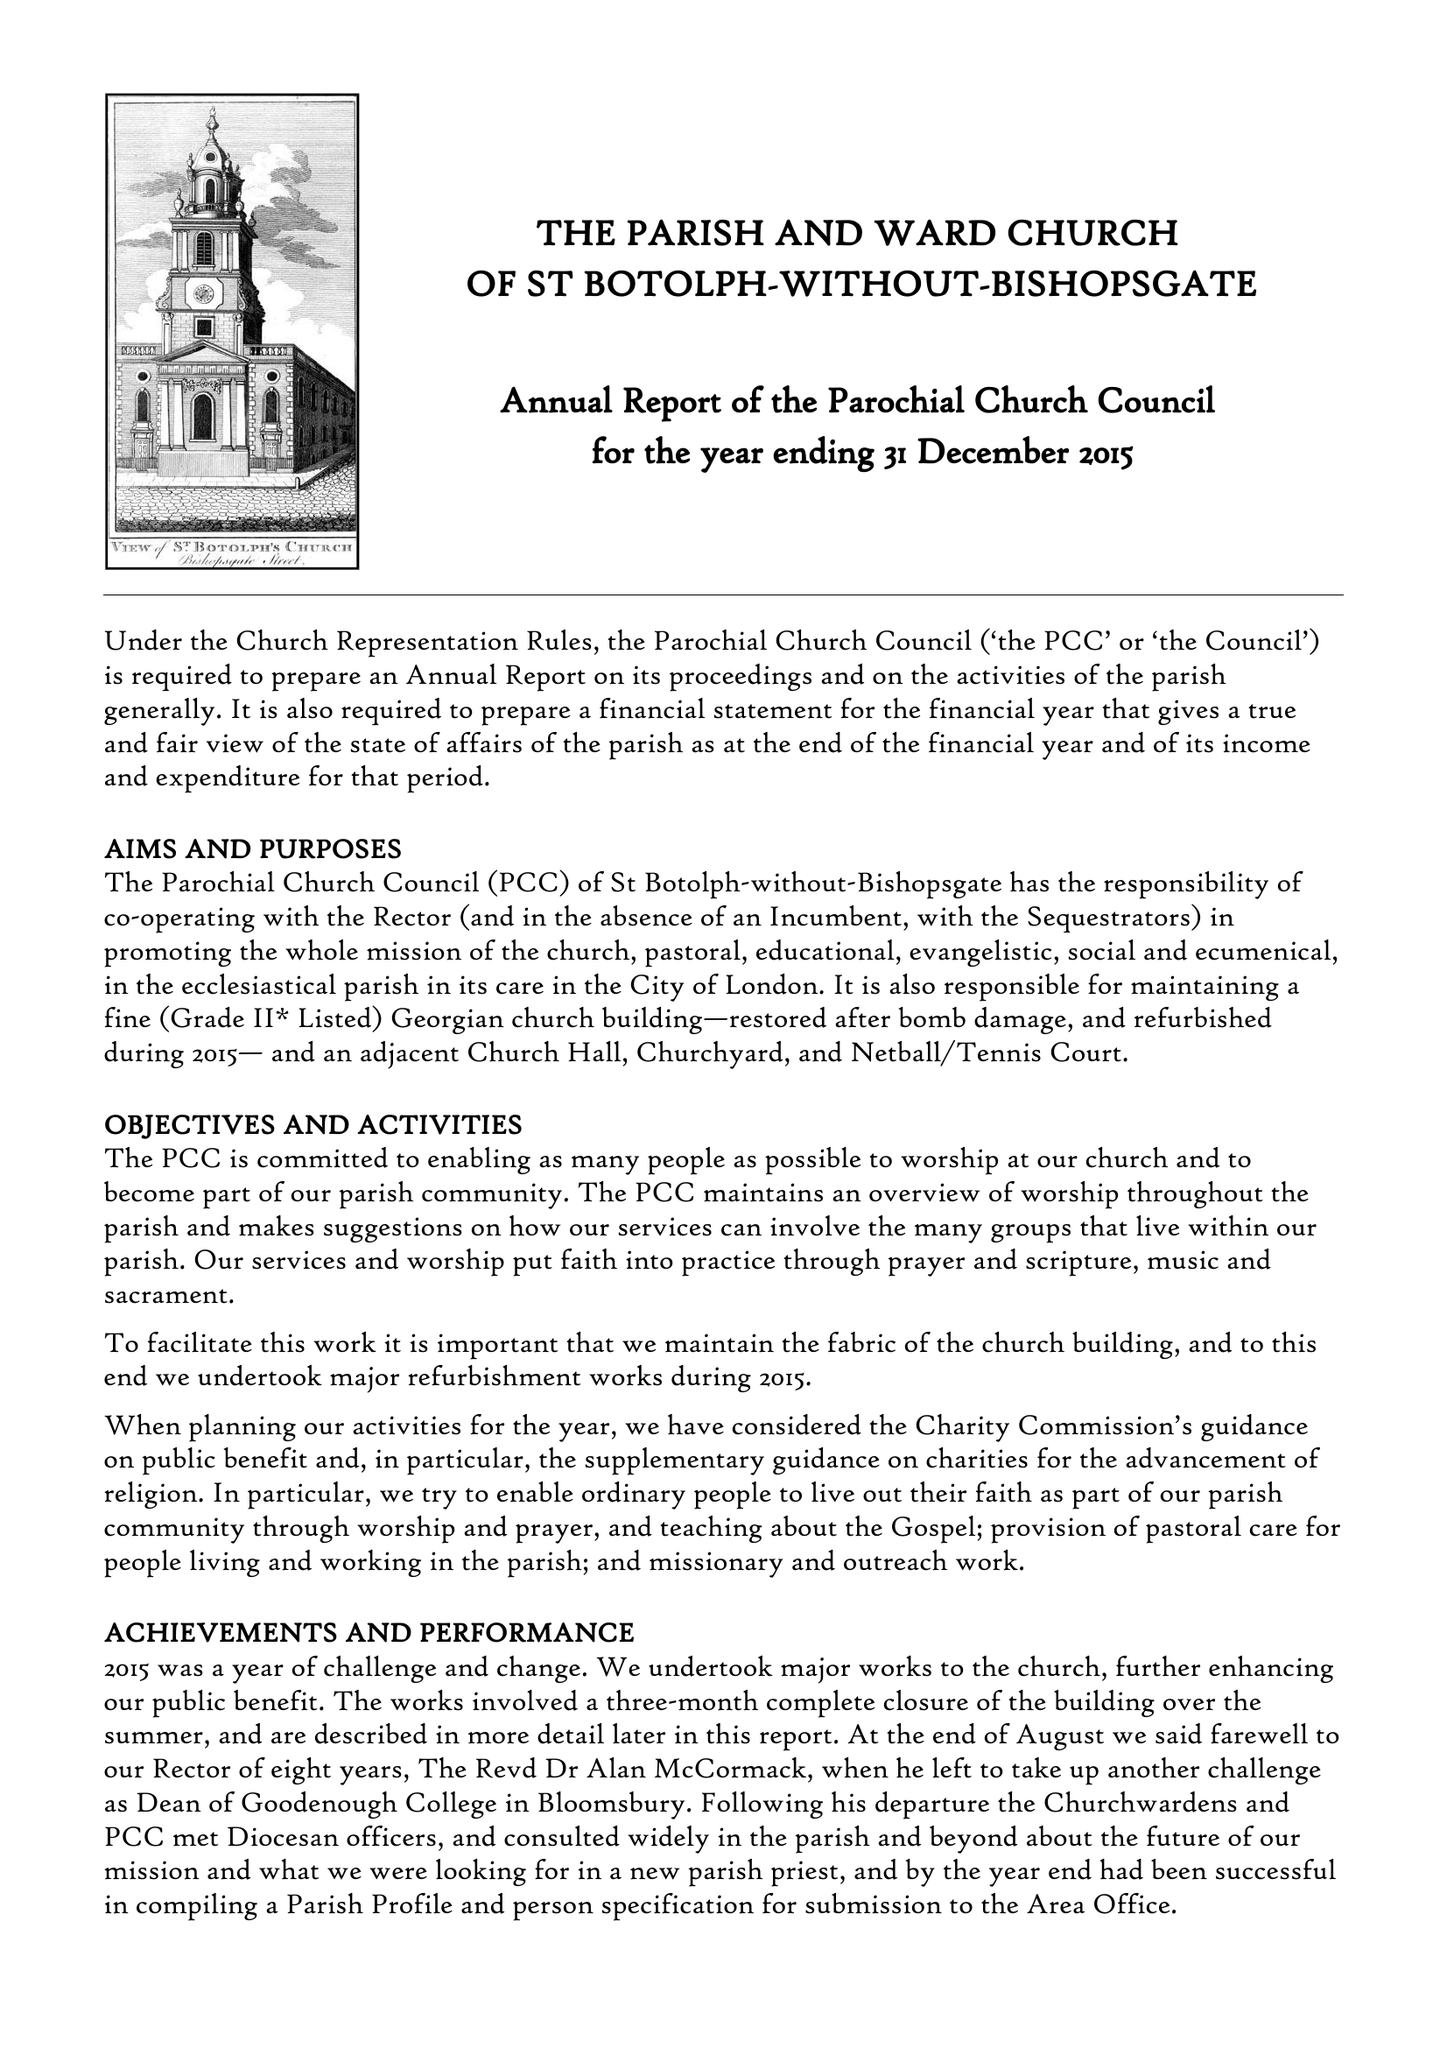What is the value for the spending_annually_in_british_pounds?
Answer the question using a single word or phrase. 392771.00 